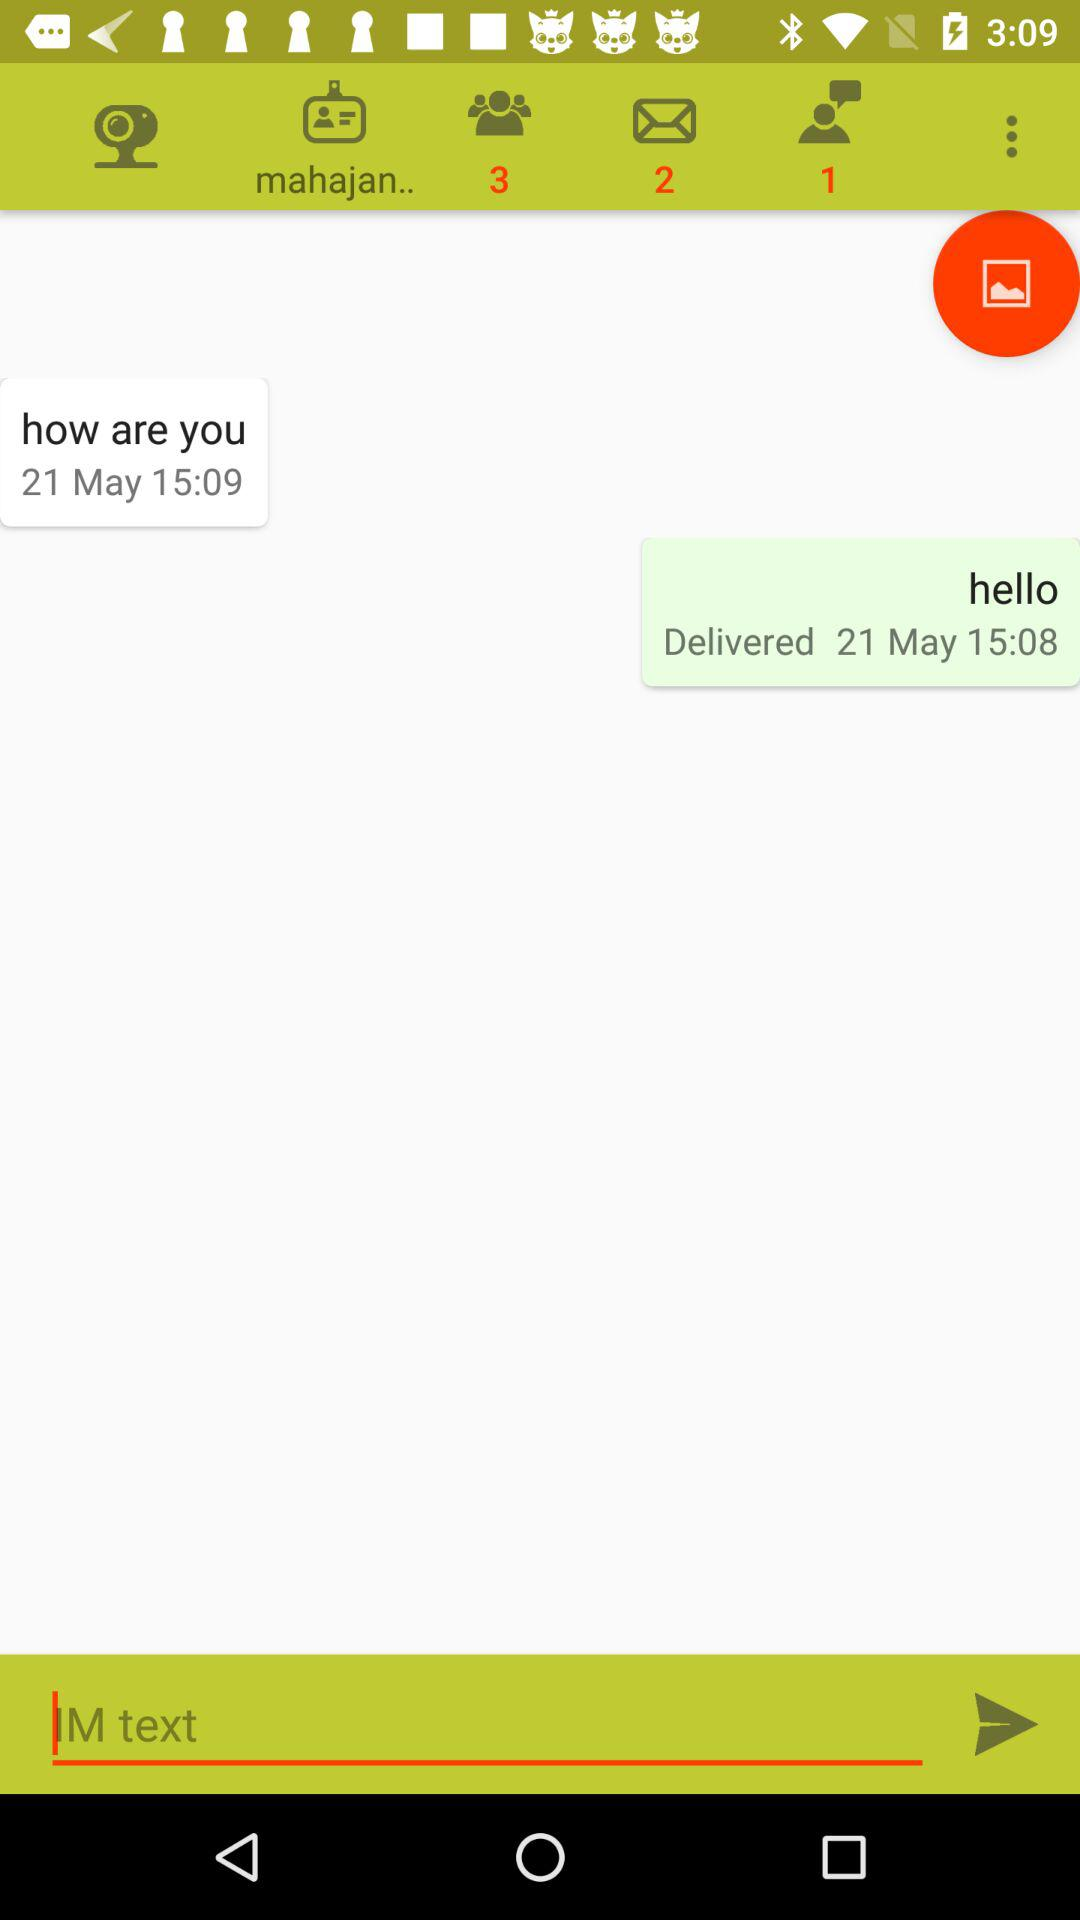At what time is the message delivered? The message is delivered at 15:08. 